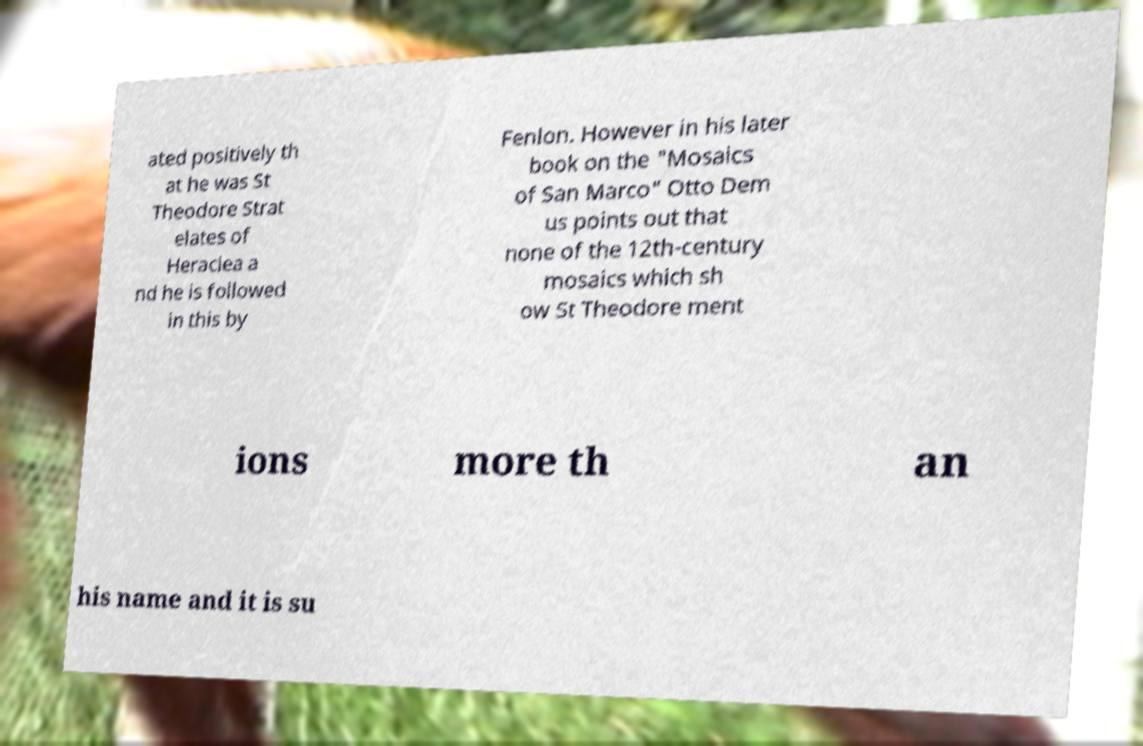Could you extract and type out the text from this image? ated positively th at he was St Theodore Strat elates of Heraclea a nd he is followed in this by Fenlon. However in his later book on the "Mosaics of San Marco" Otto Dem us points out that none of the 12th-century mosaics which sh ow St Theodore ment ions more th an his name and it is su 